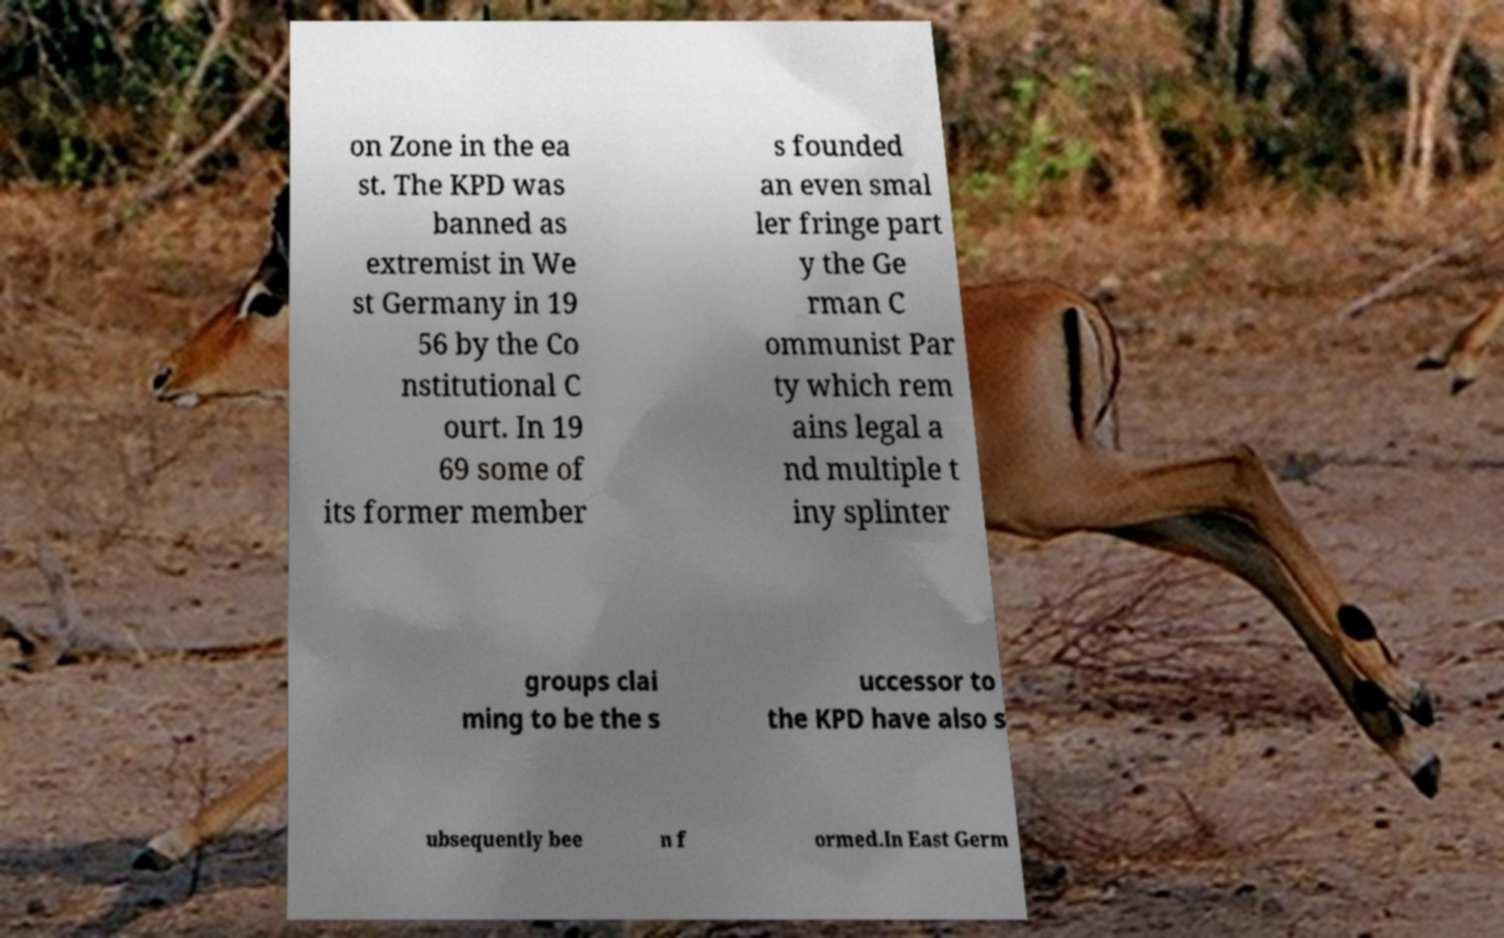What messages or text are displayed in this image? I need them in a readable, typed format. on Zone in the ea st. The KPD was banned as extremist in We st Germany in 19 56 by the Co nstitutional C ourt. In 19 69 some of its former member s founded an even smal ler fringe part y the Ge rman C ommunist Par ty which rem ains legal a nd multiple t iny splinter groups clai ming to be the s uccessor to the KPD have also s ubsequently bee n f ormed.In East Germ 